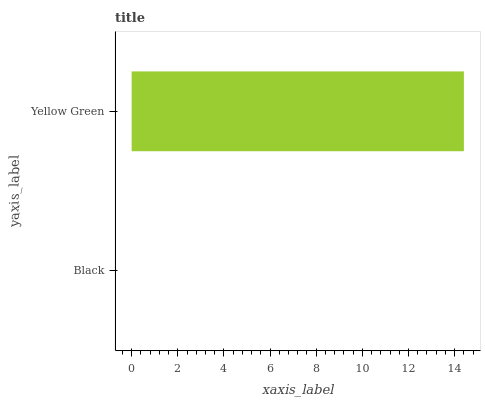Is Black the minimum?
Answer yes or no. Yes. Is Yellow Green the maximum?
Answer yes or no. Yes. Is Yellow Green the minimum?
Answer yes or no. No. Is Yellow Green greater than Black?
Answer yes or no. Yes. Is Black less than Yellow Green?
Answer yes or no. Yes. Is Black greater than Yellow Green?
Answer yes or no. No. Is Yellow Green less than Black?
Answer yes or no. No. Is Yellow Green the high median?
Answer yes or no. Yes. Is Black the low median?
Answer yes or no. Yes. Is Black the high median?
Answer yes or no. No. Is Yellow Green the low median?
Answer yes or no. No. 